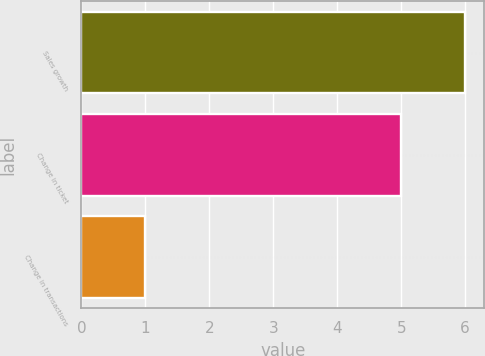Convert chart. <chart><loc_0><loc_0><loc_500><loc_500><bar_chart><fcel>Sales growth<fcel>Change in ticket<fcel>Change in transactions<nl><fcel>6<fcel>5<fcel>1<nl></chart> 